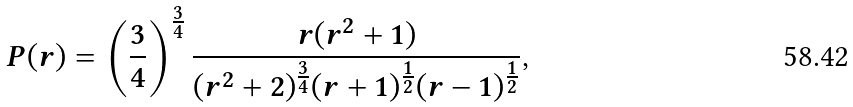<formula> <loc_0><loc_0><loc_500><loc_500>P ( r ) = \left ( \frac { 3 } { 4 } \right ) ^ { \frac { 3 } { 4 } } \frac { r ( r ^ { 2 } + 1 ) } { ( r ^ { 2 } + 2 ) ^ { \frac { 3 } { 4 } } ( r + 1 ) ^ { \frac { 1 } { 2 } } ( r - 1 ) ^ { \frac { 1 } { 2 } } } ,</formula> 